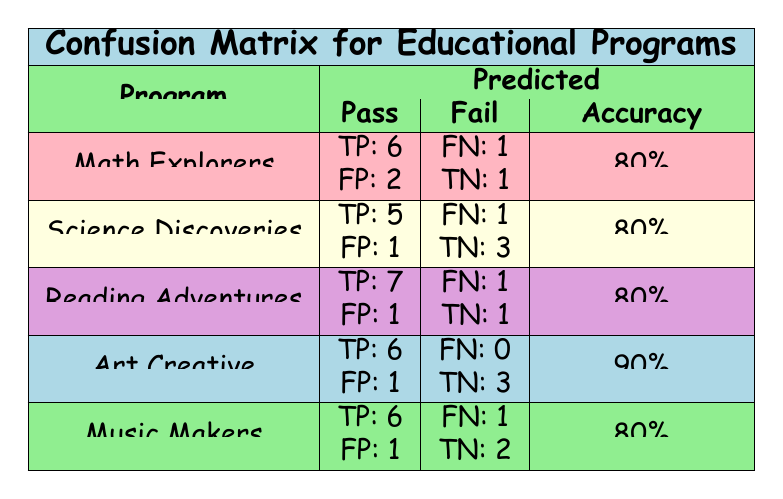What is the accuracy of the "Art Creative" program? The table shows that the accuracy for the "Art Creative" program is listed in the "Accuracy" column, and it states 90%.
Answer: 90% How many true positives does the "Music Makers" program have? For the "Music Makers" row, the true positives (TP) value is specified as 6 in the “Pass” column.
Answer: 6 What is the total number of false negatives across all programs? To find this, sum the false negatives (FN) for each program: Math Explorers (1) + Science Discoveries (1) + Reading Adventures (1) + Art Creative (0) + Music Makers (1) = 1 + 1 + 1 + 0 + 1 = 4.
Answer: 4 Did the "Science Discoveries" program have more true negatives than false positives? The "Science Discoveries" row indicates it has 3 true negatives (TN) and 1 false positive (FP). Since 3 is greater than 1, the answer is yes.
Answer: Yes Which program has the highest number of true positives? By reviewing the true positives for each program, Math Explorers has 6, Science Discoveries has 5, Reading Adventures has 7, Art Creative has 6, and Music Makers has 6. The highest value is 7 from the "Reading Adventures".
Answer: Reading Adventures What is the difference between the true positive counts of the "Reading Adventures" and "Science Discoveries"? The true positives for "Reading Adventures" is 7 and for "Science Discoveries" is 5. The difference is 7 - 5 = 2.
Answer: 2 Are there any programs that report a true positive of 0? By examining the table, none of the programs have a true positive (TP) count of 0. All programs report at least some positive identifications of successful results.
Answer: No What is the total number of predicted passes for the "Math Explorers" program? The predicted labels for "Math Explorers" contain 8 "Pass" entries out of 10 total attempts, reflecting a majority prediction of passing.
Answer: 8 Is the accuracy of the "Music Makers" program equal to the accuracy of the "Math Explorers" program? Both "Music Makers" and "Math Explorers" have an accuracy of 80%, indicating that their performance in predicting passes is the same.
Answer: Yes 